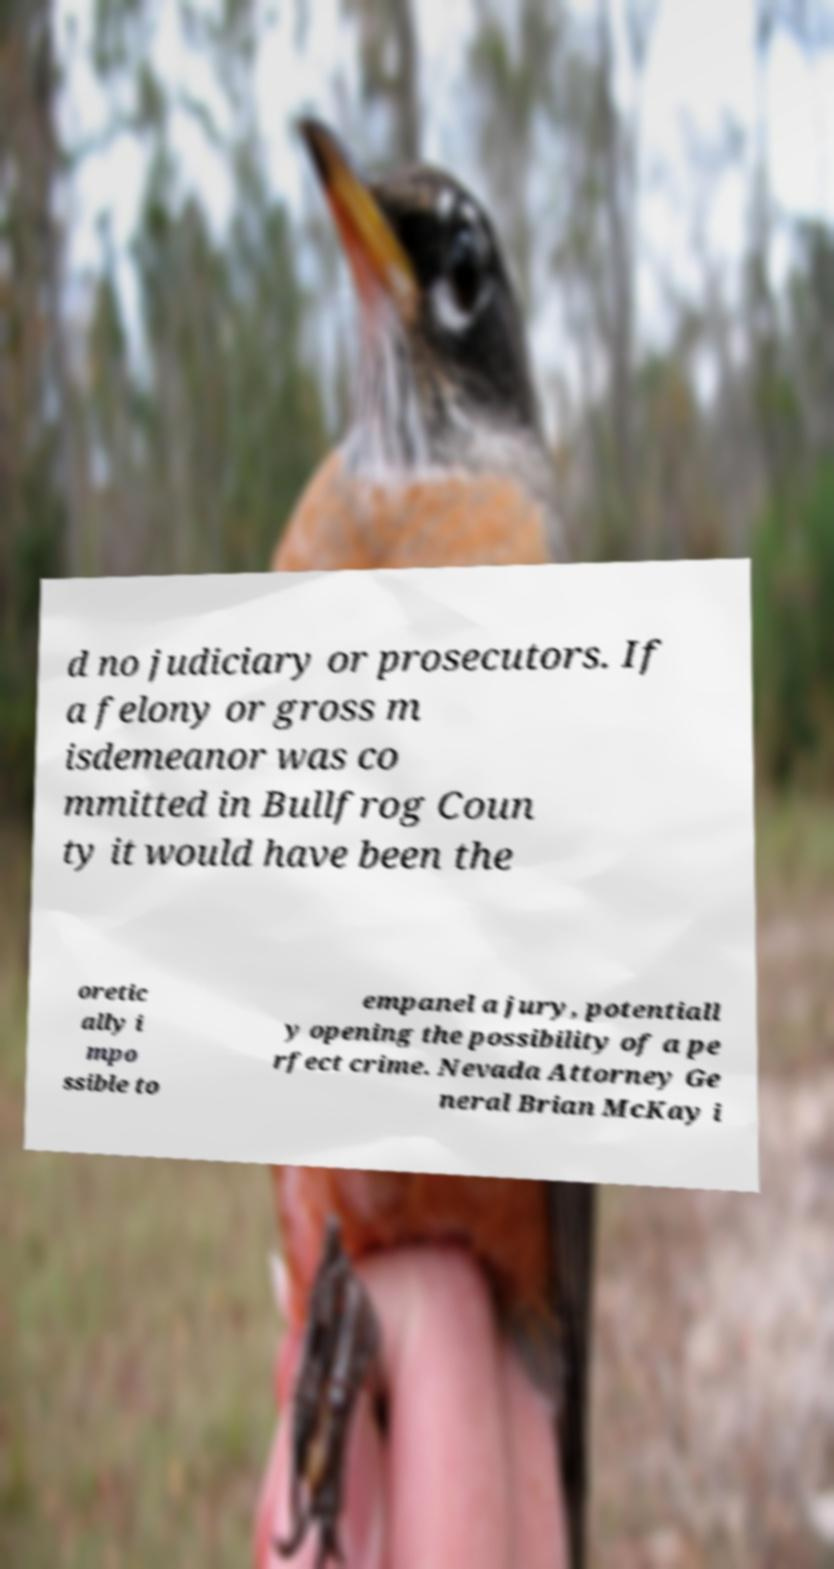I need the written content from this picture converted into text. Can you do that? d no judiciary or prosecutors. If a felony or gross m isdemeanor was co mmitted in Bullfrog Coun ty it would have been the oretic ally i mpo ssible to empanel a jury, potentiall y opening the possibility of a pe rfect crime. Nevada Attorney Ge neral Brian McKay i 